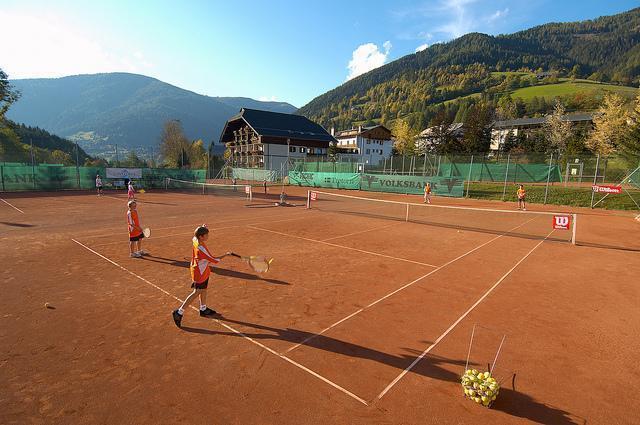What event is being carried out?
From the following four choices, select the correct answer to address the question.
Options: Tennis training, tennis competition, badminton training, badminton competition. Tennis training. 